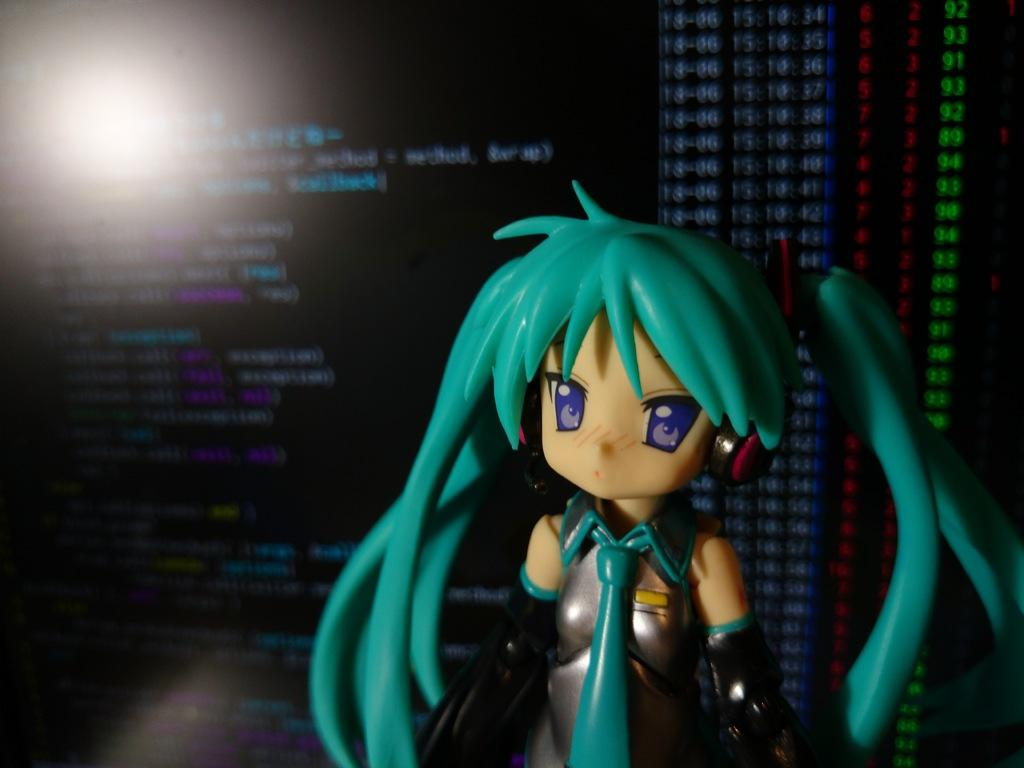What object can be seen in the image? There is a toy in the image. What can be seen in the background of the image? There is a screen in the background of the image. What type of pear is being used as a prop for the toy in the image? There is no pear present in the image, and the toy is not interacting with any fruit. 